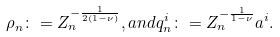Convert formula to latex. <formula><loc_0><loc_0><loc_500><loc_500>\rho _ { n } \colon = Z _ { n } ^ { - \frac { 1 } { 2 ( 1 - \nu ) } } , a n d q _ { n } ^ { i } \colon = Z _ { n } ^ { - \frac { 1 } { 1 - \nu } } a ^ { i } .</formula> 